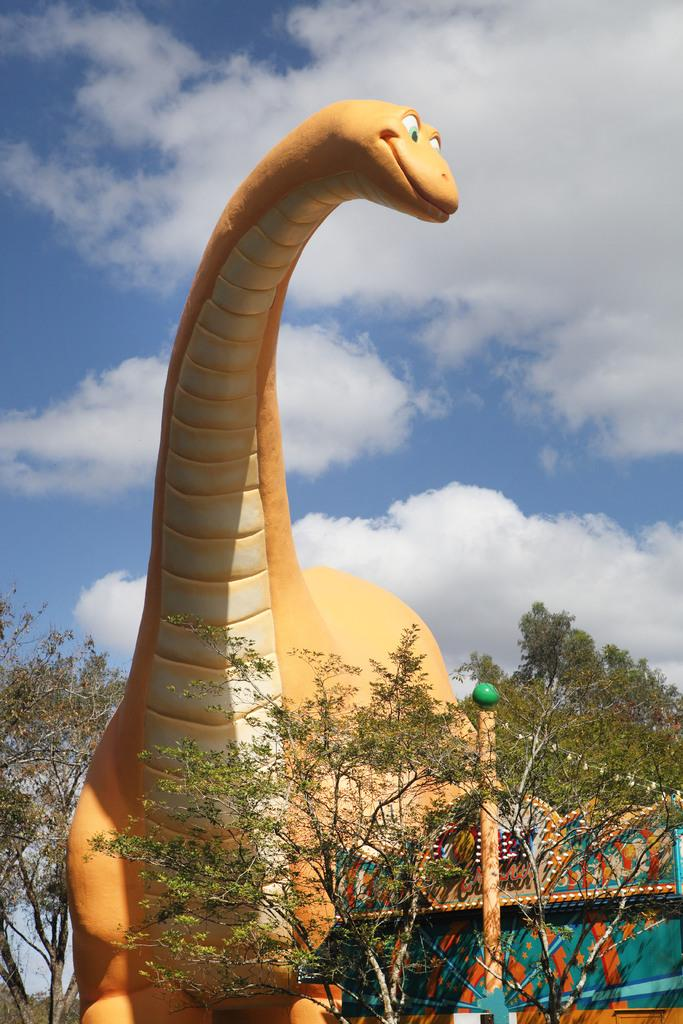What type of toy is present in the image? There is a toy dinosaur in the image. What natural elements can be seen in the image? There are trees, plants, and the sky visible in the image. What man-made object is present in the image? There is a pole in the image. Where are some objects located in the image? There are objects on the bottom right of the image. What is the condition of the sky in the image? The sky is visible in the image, and clouds are present. What type of winter clothing is the toy dinosaur wearing in the image? The toy dinosaur is not wearing any winter clothing, as it is a toy and not a living being. 